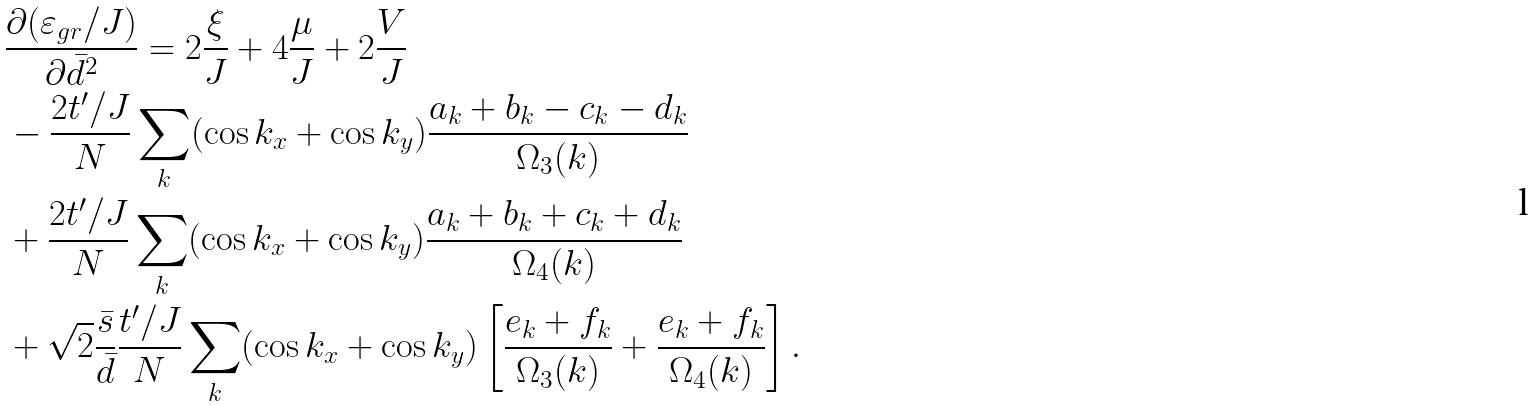Convert formula to latex. <formula><loc_0><loc_0><loc_500><loc_500>& \frac { \partial ( \varepsilon _ { g r } / J ) } { \partial \bar { d } ^ { 2 } } = 2 \frac { \xi } { J } + 4 \frac { \mu } { J } + 2 \frac { V } { J } \\ & - \frac { 2 t ^ { \prime } / J } { N } \sum _ { k } ( \cos { k _ { x } } + \cos { k _ { y } } ) \frac { a _ { k } + b _ { k } - c _ { k } - d _ { k } } { \Omega _ { 3 } ( k ) } \\ & + \frac { 2 t ^ { \prime } / J } { N } \sum _ { k } ( \cos { k _ { x } } + \cos { k _ { y } } ) \frac { a _ { k } + b _ { k } + c _ { k } + d _ { k } } { \Omega _ { 4 } ( k ) } \\ & + \sqrt { 2 } \frac { \bar { s } } { \bar { d } } \frac { t ^ { \prime } / J } { N } \sum _ { k } ( \cos { k _ { x } } + \cos { k _ { y } } ) \left [ \frac { e _ { k } + f _ { k } } { \Omega _ { 3 } ( k ) } + \frac { e _ { k } + f _ { k } } { \Omega _ { 4 } ( k ) } \right ] .</formula> 